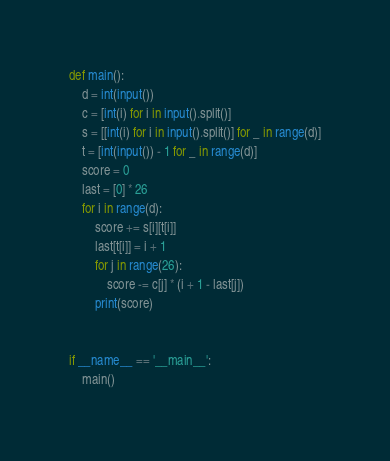<code> <loc_0><loc_0><loc_500><loc_500><_Python_>def main():
    d = int(input())
    c = [int(i) for i in input().split()]
    s = [[int(i) for i in input().split()] for _ in range(d)]
    t = [int(input()) - 1 for _ in range(d)]
    score = 0
    last = [0] * 26
    for i in range(d):
        score += s[i][t[i]]
        last[t[i]] = i + 1
        for j in range(26):
            score -= c[j] * (i + 1 - last[j])
        print(score)


if __name__ == '__main__':
    main()
</code> 